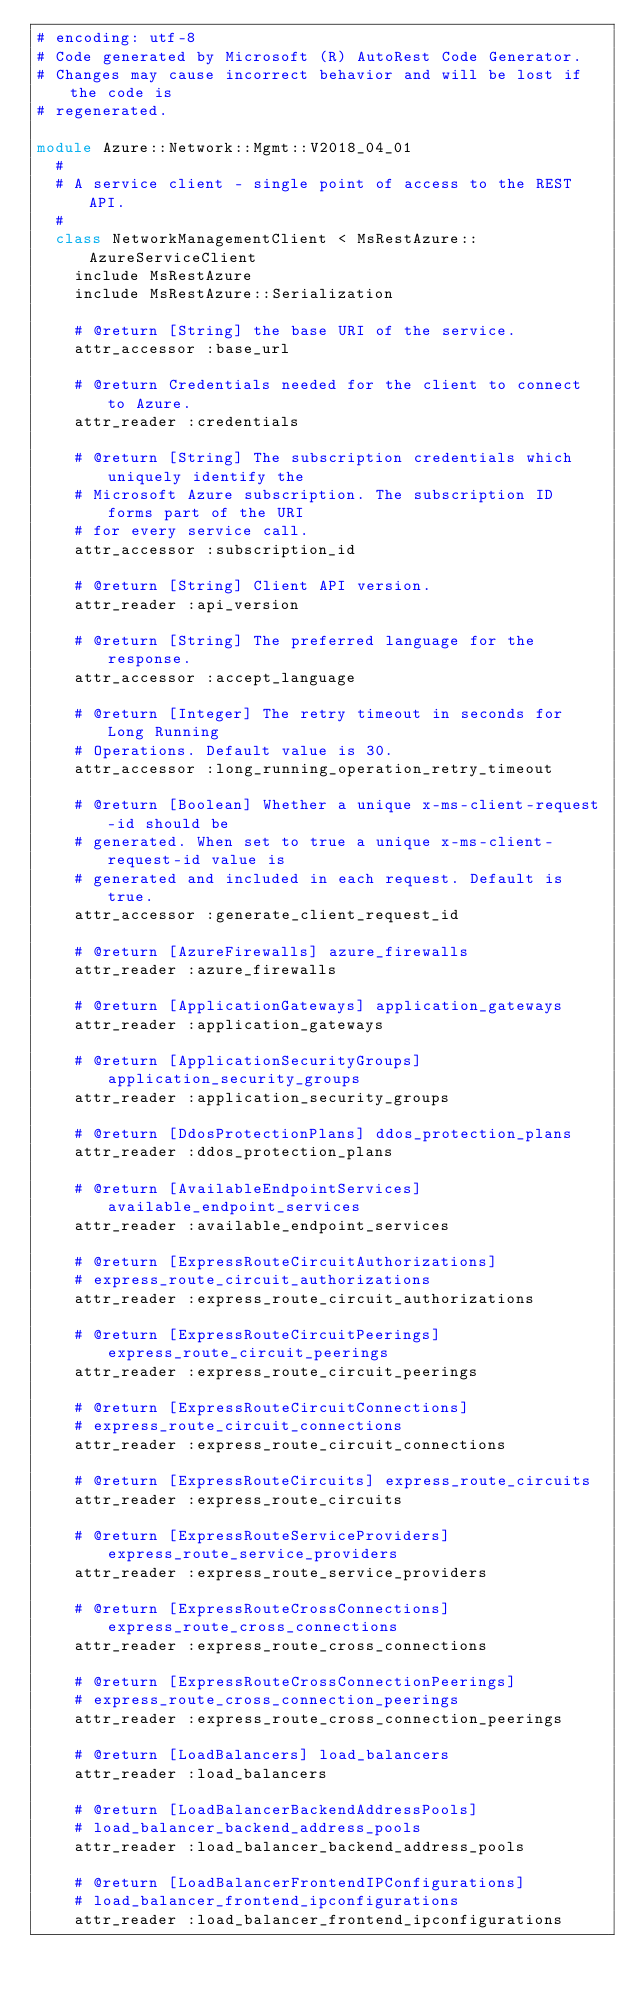Convert code to text. <code><loc_0><loc_0><loc_500><loc_500><_Ruby_># encoding: utf-8
# Code generated by Microsoft (R) AutoRest Code Generator.
# Changes may cause incorrect behavior and will be lost if the code is
# regenerated.

module Azure::Network::Mgmt::V2018_04_01
  #
  # A service client - single point of access to the REST API.
  #
  class NetworkManagementClient < MsRestAzure::AzureServiceClient
    include MsRestAzure
    include MsRestAzure::Serialization

    # @return [String] the base URI of the service.
    attr_accessor :base_url

    # @return Credentials needed for the client to connect to Azure.
    attr_reader :credentials

    # @return [String] The subscription credentials which uniquely identify the
    # Microsoft Azure subscription. The subscription ID forms part of the URI
    # for every service call.
    attr_accessor :subscription_id

    # @return [String] Client API version.
    attr_reader :api_version

    # @return [String] The preferred language for the response.
    attr_accessor :accept_language

    # @return [Integer] The retry timeout in seconds for Long Running
    # Operations. Default value is 30.
    attr_accessor :long_running_operation_retry_timeout

    # @return [Boolean] Whether a unique x-ms-client-request-id should be
    # generated. When set to true a unique x-ms-client-request-id value is
    # generated and included in each request. Default is true.
    attr_accessor :generate_client_request_id

    # @return [AzureFirewalls] azure_firewalls
    attr_reader :azure_firewalls

    # @return [ApplicationGateways] application_gateways
    attr_reader :application_gateways

    # @return [ApplicationSecurityGroups] application_security_groups
    attr_reader :application_security_groups

    # @return [DdosProtectionPlans] ddos_protection_plans
    attr_reader :ddos_protection_plans

    # @return [AvailableEndpointServices] available_endpoint_services
    attr_reader :available_endpoint_services

    # @return [ExpressRouteCircuitAuthorizations]
    # express_route_circuit_authorizations
    attr_reader :express_route_circuit_authorizations

    # @return [ExpressRouteCircuitPeerings] express_route_circuit_peerings
    attr_reader :express_route_circuit_peerings

    # @return [ExpressRouteCircuitConnections]
    # express_route_circuit_connections
    attr_reader :express_route_circuit_connections

    # @return [ExpressRouteCircuits] express_route_circuits
    attr_reader :express_route_circuits

    # @return [ExpressRouteServiceProviders] express_route_service_providers
    attr_reader :express_route_service_providers

    # @return [ExpressRouteCrossConnections] express_route_cross_connections
    attr_reader :express_route_cross_connections

    # @return [ExpressRouteCrossConnectionPeerings]
    # express_route_cross_connection_peerings
    attr_reader :express_route_cross_connection_peerings

    # @return [LoadBalancers] load_balancers
    attr_reader :load_balancers

    # @return [LoadBalancerBackendAddressPools]
    # load_balancer_backend_address_pools
    attr_reader :load_balancer_backend_address_pools

    # @return [LoadBalancerFrontendIPConfigurations]
    # load_balancer_frontend_ipconfigurations
    attr_reader :load_balancer_frontend_ipconfigurations
</code> 